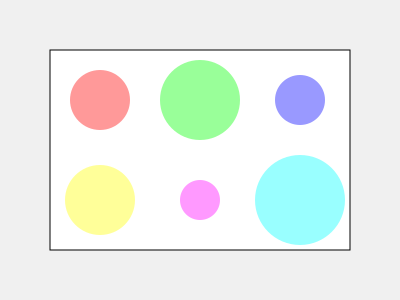Given the diagram of a rectangular table with six floral centerpieces of different sizes, what is the minimum number of moves required to arrange the centerpieces so that no two circles overlap and all circles are completely within the table's boundaries? To solve this spatial puzzle, let's follow these steps:

1. Assess the current arrangement:
   - The table is represented by the large rectangle.
   - There are 6 circular centerpieces of varying sizes.
   - Some centerpieces are overlapping or touching the table's edge.

2. Identify the overlaps and boundary issues:
   - The green and blue centerpieces in the top row are overlapping.
   - The cyan centerpiece in the bottom right is touching the table's edge.

3. Determine the minimum moves:
   - Move the blue centerpiece in the top row to the right to eliminate overlap.
   - Move the cyan centerpiece in the bottom right slightly left and up.

4. Verify the solution:
   - After these two moves, all centerpieces will be within the table's boundaries.
   - No centerpieces will be overlapping.

5. Count the moves:
   - We made 2 moves in total.

Therefore, the minimum number of moves required to arrange the centerpieces properly is 2.
Answer: 2 moves 